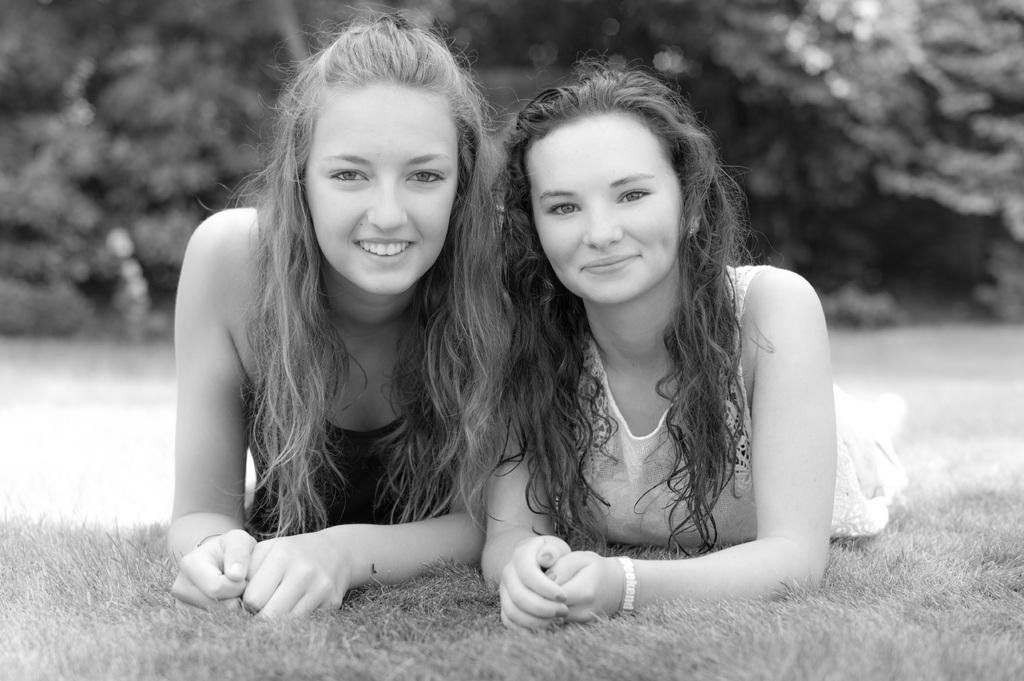What are the two ladies in the image doing? The two ladies are lying on the ground in the center of the image. What can be seen in the background of the image? There are trees in the background of the image. What is visible at the bottom of the image? The ground is visible at the bottom of the image. What type of brush is being used by the lady on the left to paint the jar in the image? There is no brush, lady on the left, or jar present in the image. 